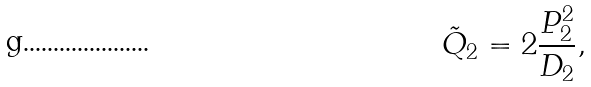Convert formula to latex. <formula><loc_0><loc_0><loc_500><loc_500>\tilde { Q } _ { 2 } = 2 \frac { P _ { 2 } ^ { 2 } } { D _ { 2 } } ,</formula> 